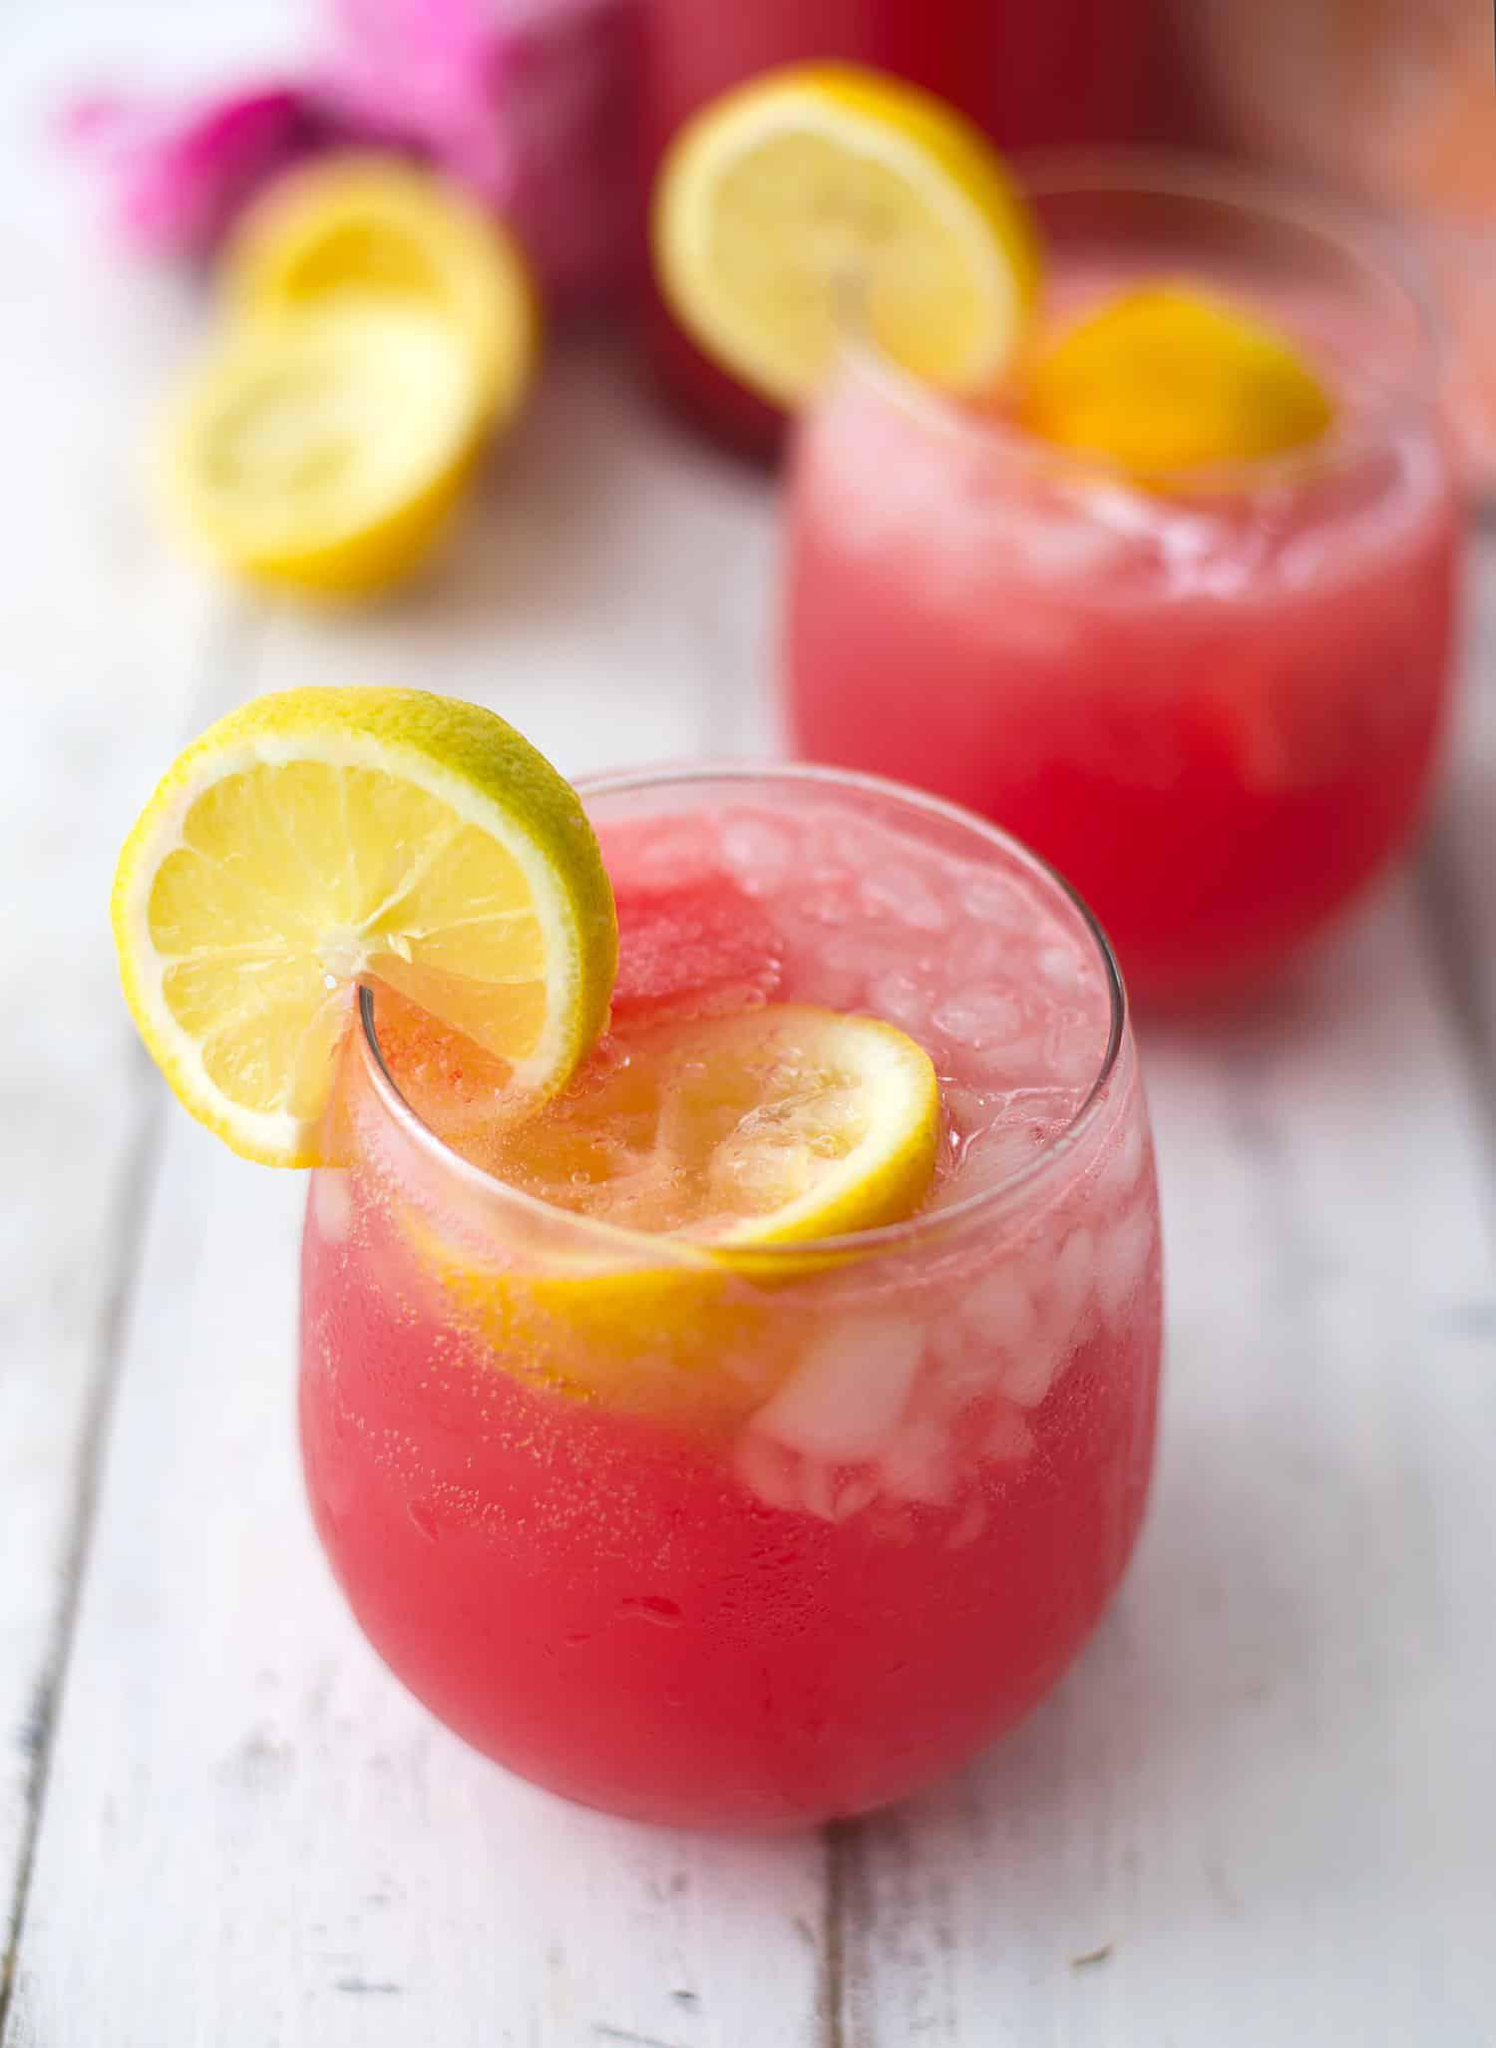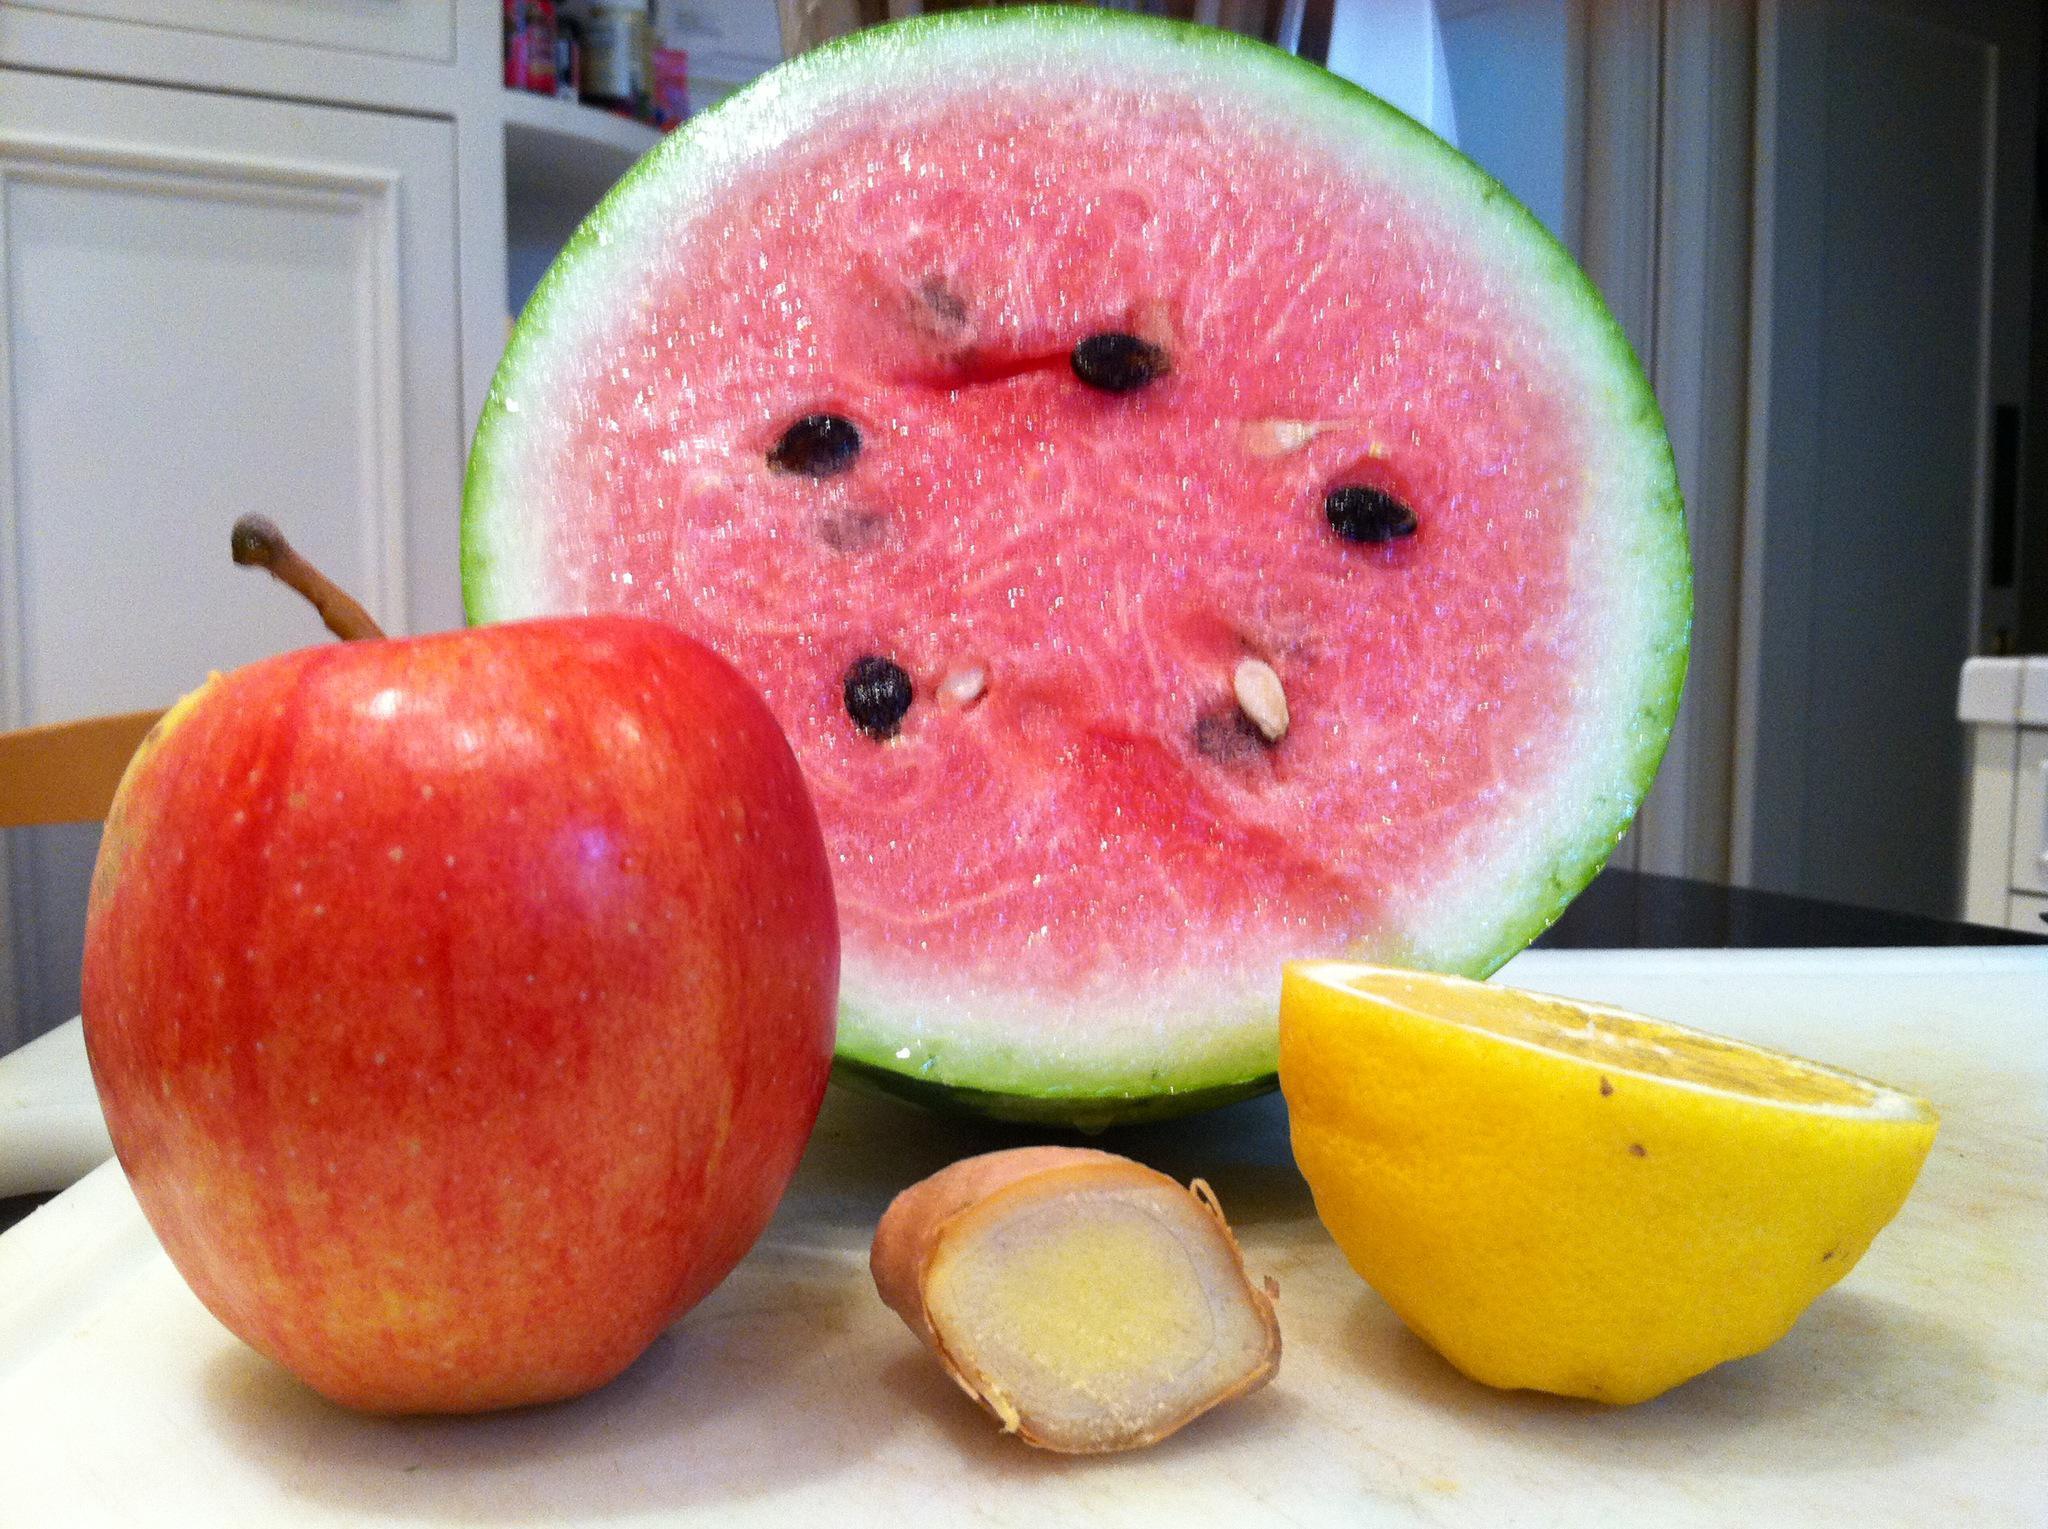The first image is the image on the left, the second image is the image on the right. Evaluate the accuracy of this statement regarding the images: "One image shows fruit in a white bowl.". Is it true? Answer yes or no. No. The first image is the image on the left, the second image is the image on the right. For the images displayed, is the sentence "In one image, multiple watermelon wedges have green rind and white area next to the red fruit." factually correct? Answer yes or no. No. 